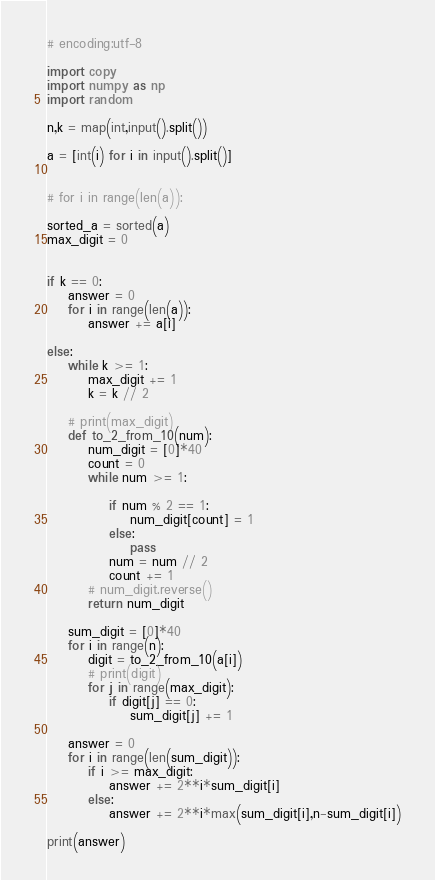Convert code to text. <code><loc_0><loc_0><loc_500><loc_500><_Python_># encoding:utf-8

import copy
import numpy as np
import random

n,k = map(int,input().split())

a = [int(i) for i in input().split()]


# for i in range(len(a)):

sorted_a = sorted(a)
max_digit = 0


if k == 0:
    answer = 0
    for i in range(len(a)):
        answer += a[i]

else:
    while k >= 1:
        max_digit += 1
        k = k // 2

    # print(max_digit)
    def to_2_from_10(num):
        num_digit = [0]*40
        count = 0
        while num >= 1:

            if num % 2 == 1:
                num_digit[count] = 1
            else:
                pass
            num = num // 2
            count += 1
        # num_digit.reverse()
        return num_digit

    sum_digit = [0]*40
    for i in range(n):
        digit = to_2_from_10(a[i])
        # print(digit)
        for j in range(max_digit):
            if digit[j] == 0:
                sum_digit[j] += 1

    answer = 0
    for i in range(len(sum_digit)):
        if i >= max_digit:
            answer += 2**i*sum_digit[i]
        else:
            answer += 2**i*max(sum_digit[i],n-sum_digit[i])

print(answer)
</code> 